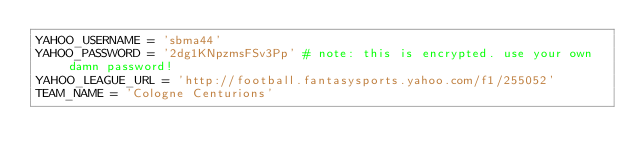<code> <loc_0><loc_0><loc_500><loc_500><_Python_>YAHOO_USERNAME = 'sbma44'
YAHOO_PASSWORD = '2dg1KNpzmsFSv3Pp' # note: this is encrypted. use your own damn password!
YAHOO_LEAGUE_URL = 'http://football.fantasysports.yahoo.com/f1/255052'
TEAM_NAME = 'Cologne Centurions'</code> 